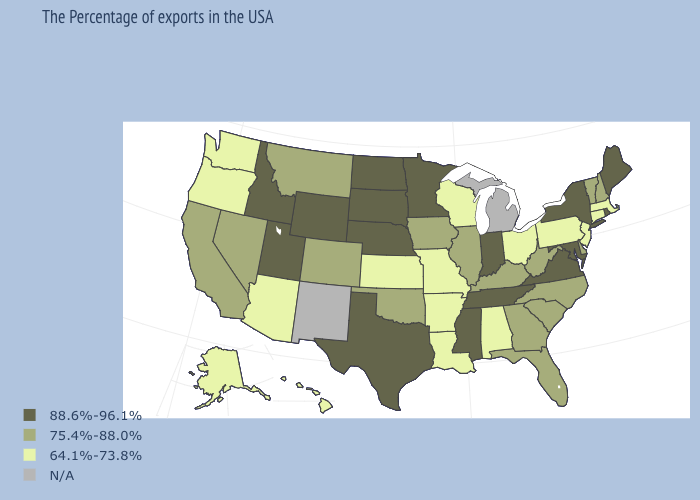What is the lowest value in states that border Massachusetts?
Concise answer only. 64.1%-73.8%. What is the value of Wisconsin?
Keep it brief. 64.1%-73.8%. Name the states that have a value in the range 64.1%-73.8%?
Write a very short answer. Massachusetts, Connecticut, New Jersey, Pennsylvania, Ohio, Alabama, Wisconsin, Louisiana, Missouri, Arkansas, Kansas, Arizona, Washington, Oregon, Alaska, Hawaii. Among the states that border Kentucky , which have the lowest value?
Keep it brief. Ohio, Missouri. Among the states that border Kentucky , does Virginia have the highest value?
Quick response, please. Yes. What is the highest value in the MidWest ?
Give a very brief answer. 88.6%-96.1%. What is the highest value in the South ?
Be succinct. 88.6%-96.1%. What is the lowest value in the USA?
Be succinct. 64.1%-73.8%. What is the lowest value in the USA?
Concise answer only. 64.1%-73.8%. What is the value of Montana?
Write a very short answer. 75.4%-88.0%. Which states have the lowest value in the West?
Answer briefly. Arizona, Washington, Oregon, Alaska, Hawaii. What is the lowest value in the USA?
Keep it brief. 64.1%-73.8%. What is the highest value in the West ?
Be succinct. 88.6%-96.1%. What is the value of Vermont?
Be succinct. 75.4%-88.0%. Among the states that border Georgia , does Tennessee have the highest value?
Keep it brief. Yes. 